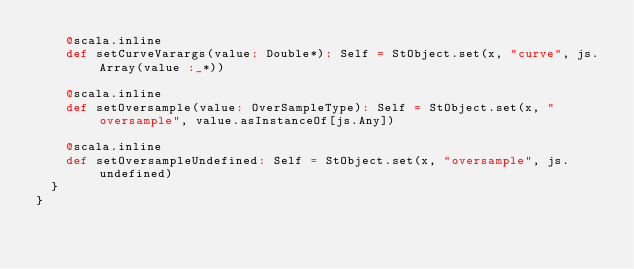Convert code to text. <code><loc_0><loc_0><loc_500><loc_500><_Scala_>    @scala.inline
    def setCurveVarargs(value: Double*): Self = StObject.set(x, "curve", js.Array(value :_*))
    
    @scala.inline
    def setOversample(value: OverSampleType): Self = StObject.set(x, "oversample", value.asInstanceOf[js.Any])
    
    @scala.inline
    def setOversampleUndefined: Self = StObject.set(x, "oversample", js.undefined)
  }
}
</code> 